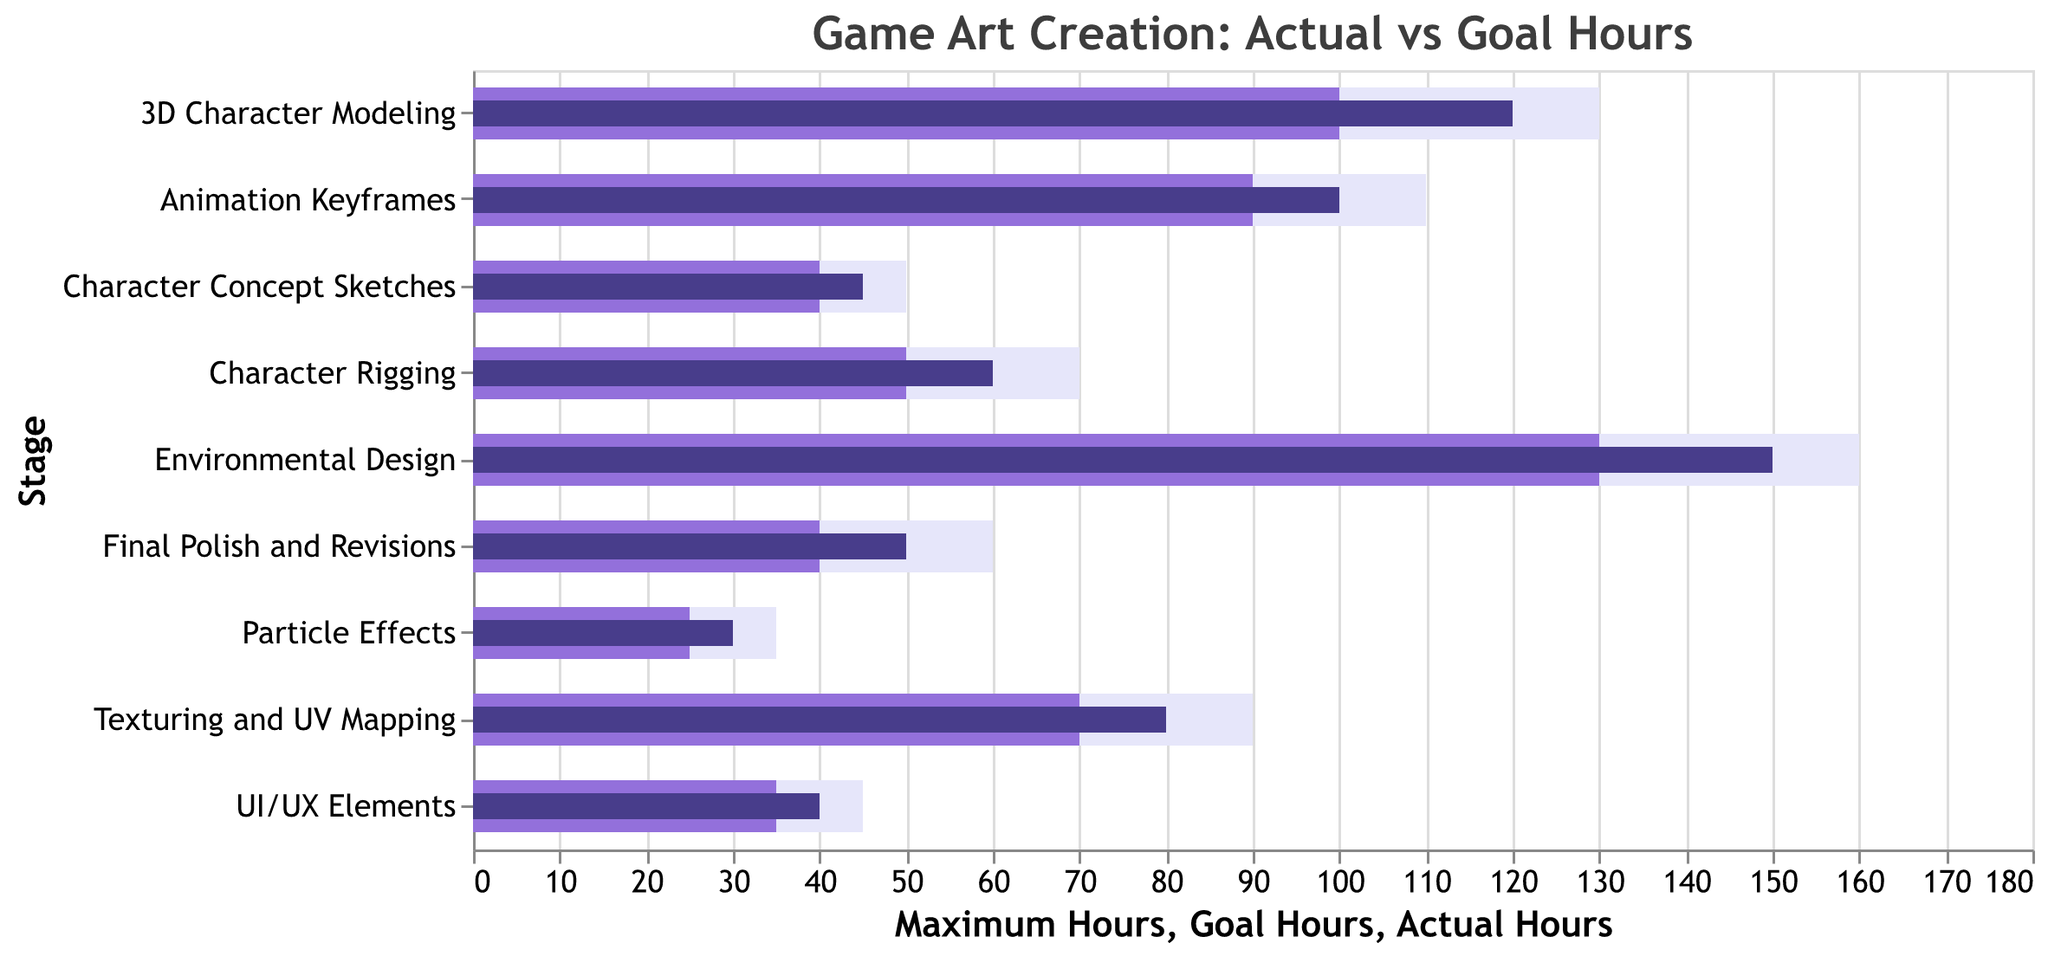What is the actual time spent on Environmental Design? The figure shows the time spent on various stages of game art creation. Looking at Environmental Design, the actual hours bar indicates 150 hours.
Answer: 150 hours Which stage has the smallest difference between actual hours and goal hours? To find the smallest difference, we need to subtract the goal hours from the actual hours for each stage: Character Concept Sketches (45-40=5), 3D Character Modeling (120-100=20), Texturing and UV Mapping (80-70=10), Character Rigging (60-50=10), Animation Keyframes (100-90=10), Environmental Design (150-130=20), UI/UX Elements (40-35=5), Particle Effects (30-25=5), Final Polish and Revisions (50-40=10). The smallest differences are for Character Concept Sketches, UI/UX Elements, and Particle Effects.
Answer: 5 hours Which stage exceeded its goal hours the most? By comparing the actual hours to the goal hours for each stage, the stage that exceeded its goal hours the most would be the one with the largest positive difference: Character Concept Sketches (45-40=5), 3D Character Modeling (120-100=20), Texturing and UV Mapping (80-70=10), Character Rigging (60-50=10), Animation Keyframes (100-90=10), Environmental Design (150-130=20), UI/UX Elements (40-35=5), Particle Effects (30-25=5), Final Polish and Revisions (50-40=10). The largest exceedance is observed in 3D Character Modeling and Environmental Design.
Answer: 20 hours What is the total number of goal hours for all stages combined? Sum the goal hours for all stages: 40 (Character Concept Sketches) + 100 (3D Character Modeling) + 70 (Texturing and UV Mapping) + 50 (Character Rigging) + 90 (Animation Keyframes) + 130 (Environmental Design) + 35 (UI/UX Elements) + 25 (Particle Effects) + 40 (Final Polish and Revisions). The total is 580 hours.
Answer: 580 hours In which stage are the actual hours equal to the goal hours? By comparing the actual hours and goal hours for each stage, we find that in none of the stages are the actual hours equal to the goal hours.
Answer: None By how many hours did the Environmental Design stage exceed the goal hours? For Environmental Design, subtract the goal hours from the actual hours (150 - 130).
Answer: 20 hours What are the stages where the actual hours are within the maximum hours but exceed the goal hours? Check if the actual hours are greater than goal hours but less than or equal to maximum hours: Character Concept Sketches (45/40/50), 3D Character Modeling (120/100/130), Texturing and UV Mapping (80/70/90), Character Rigging (60/50/70), Animation Keyframes (100/90/110), Environmental Design (150/130/160), UI/UX Elements (40/35/45), Particle Effects (30/25/35), Final Polish and Revisions (50/40/60). All stages meet this criterion.
Answer: All stages Which stages have actual hours less than the maximum hours specified? Compare actual hours with the maximum hours for each stage. If actual hours less than maximum hours: Character Concept Sketches (45<50), 3D Character Modeling (120<130), Texturing and UV Mapping (80<90), Character Rigging (60<70), Animation Keyframes (100<110), Environmental Design (150<160), UI/UX Elements (40<45), Particle Effects (30<35), Final Polish and Revisions (50<60). All stages meet this criterion.
Answer: All stages 